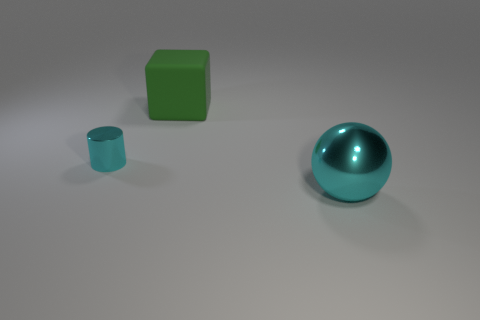What is the shape of the object that is the same size as the shiny sphere?
Provide a succinct answer. Cube. There is a metal thing that is to the left of the big metal object; does it have the same size as the metal object right of the cube?
Your answer should be very brief. No. There is a small thing that is the same material as the big cyan sphere; what color is it?
Provide a short and direct response. Cyan. Does the cyan thing behind the big metal thing have the same material as the big object behind the metal sphere?
Provide a succinct answer. No. Is there a metal object of the same size as the rubber cube?
Give a very brief answer. Yes. There is a cyan thing to the left of the cyan object on the right side of the tiny object; what is its size?
Offer a terse response. Small. What number of small metal cylinders have the same color as the small thing?
Make the answer very short. 0. What shape is the cyan object that is in front of the metal thing on the left side of the large green matte block?
Provide a succinct answer. Sphere. How many small cyan cylinders are made of the same material as the green cube?
Ensure brevity in your answer.  0. What is the material of the cyan object behind the large metal sphere?
Offer a very short reply. Metal. 